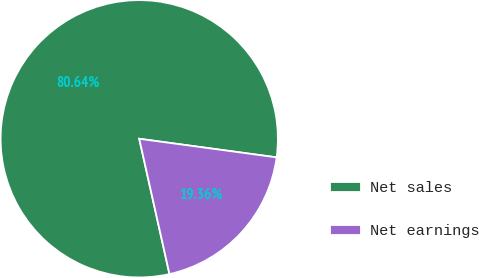Convert chart to OTSL. <chart><loc_0><loc_0><loc_500><loc_500><pie_chart><fcel>Net sales<fcel>Net earnings<nl><fcel>80.64%<fcel>19.36%<nl></chart> 